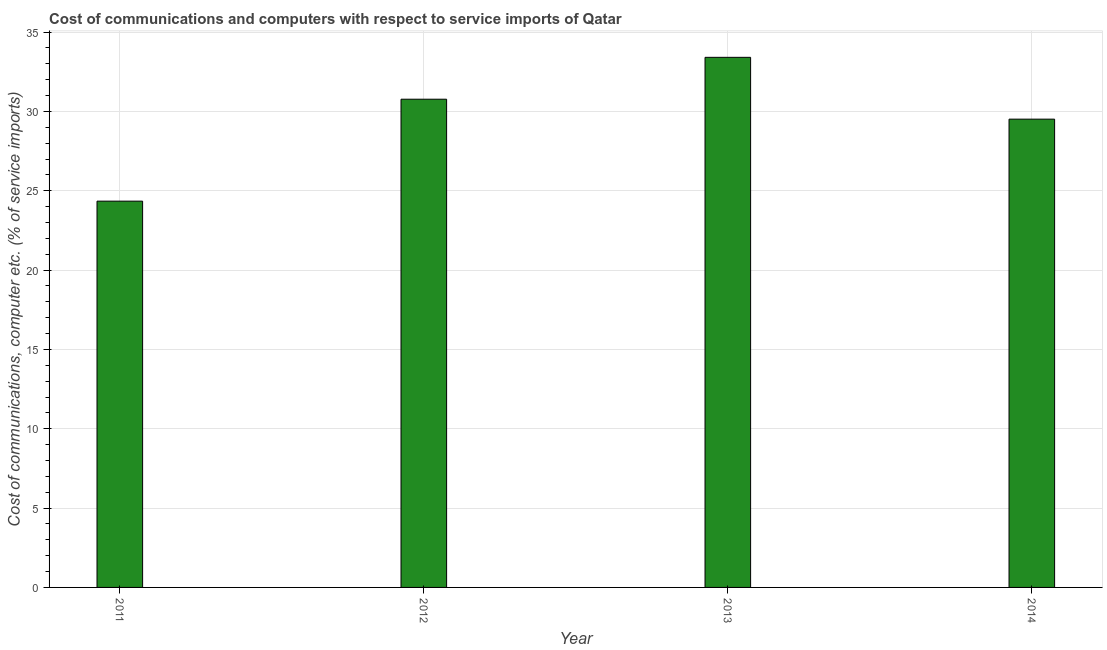What is the title of the graph?
Ensure brevity in your answer.  Cost of communications and computers with respect to service imports of Qatar. What is the label or title of the Y-axis?
Ensure brevity in your answer.  Cost of communications, computer etc. (% of service imports). What is the cost of communications and computer in 2014?
Your answer should be very brief. 29.51. Across all years, what is the maximum cost of communications and computer?
Make the answer very short. 33.41. Across all years, what is the minimum cost of communications and computer?
Ensure brevity in your answer.  24.35. In which year was the cost of communications and computer minimum?
Offer a very short reply. 2011. What is the sum of the cost of communications and computer?
Offer a very short reply. 118.05. What is the difference between the cost of communications and computer in 2013 and 2014?
Ensure brevity in your answer.  3.9. What is the average cost of communications and computer per year?
Your answer should be very brief. 29.51. What is the median cost of communications and computer?
Your answer should be very brief. 30.14. Do a majority of the years between 2014 and 2012 (inclusive) have cost of communications and computer greater than 12 %?
Offer a terse response. Yes. What is the ratio of the cost of communications and computer in 2011 to that in 2013?
Provide a succinct answer. 0.73. What is the difference between the highest and the second highest cost of communications and computer?
Your response must be concise. 2.64. What is the difference between the highest and the lowest cost of communications and computer?
Your answer should be very brief. 9.06. In how many years, is the cost of communications and computer greater than the average cost of communications and computer taken over all years?
Offer a very short reply. 3. Are all the bars in the graph horizontal?
Provide a short and direct response. No. How many years are there in the graph?
Provide a succinct answer. 4. What is the Cost of communications, computer etc. (% of service imports) in 2011?
Your answer should be very brief. 24.35. What is the Cost of communications, computer etc. (% of service imports) in 2012?
Ensure brevity in your answer.  30.77. What is the Cost of communications, computer etc. (% of service imports) of 2013?
Your answer should be compact. 33.41. What is the Cost of communications, computer etc. (% of service imports) of 2014?
Offer a terse response. 29.51. What is the difference between the Cost of communications, computer etc. (% of service imports) in 2011 and 2012?
Offer a terse response. -6.42. What is the difference between the Cost of communications, computer etc. (% of service imports) in 2011 and 2013?
Ensure brevity in your answer.  -9.06. What is the difference between the Cost of communications, computer etc. (% of service imports) in 2011 and 2014?
Offer a terse response. -5.17. What is the difference between the Cost of communications, computer etc. (% of service imports) in 2012 and 2013?
Provide a short and direct response. -2.64. What is the difference between the Cost of communications, computer etc. (% of service imports) in 2012 and 2014?
Give a very brief answer. 1.26. What is the difference between the Cost of communications, computer etc. (% of service imports) in 2013 and 2014?
Keep it short and to the point. 3.9. What is the ratio of the Cost of communications, computer etc. (% of service imports) in 2011 to that in 2012?
Offer a very short reply. 0.79. What is the ratio of the Cost of communications, computer etc. (% of service imports) in 2011 to that in 2013?
Provide a succinct answer. 0.73. What is the ratio of the Cost of communications, computer etc. (% of service imports) in 2011 to that in 2014?
Make the answer very short. 0.82. What is the ratio of the Cost of communications, computer etc. (% of service imports) in 2012 to that in 2013?
Ensure brevity in your answer.  0.92. What is the ratio of the Cost of communications, computer etc. (% of service imports) in 2012 to that in 2014?
Your answer should be compact. 1.04. What is the ratio of the Cost of communications, computer etc. (% of service imports) in 2013 to that in 2014?
Make the answer very short. 1.13. 